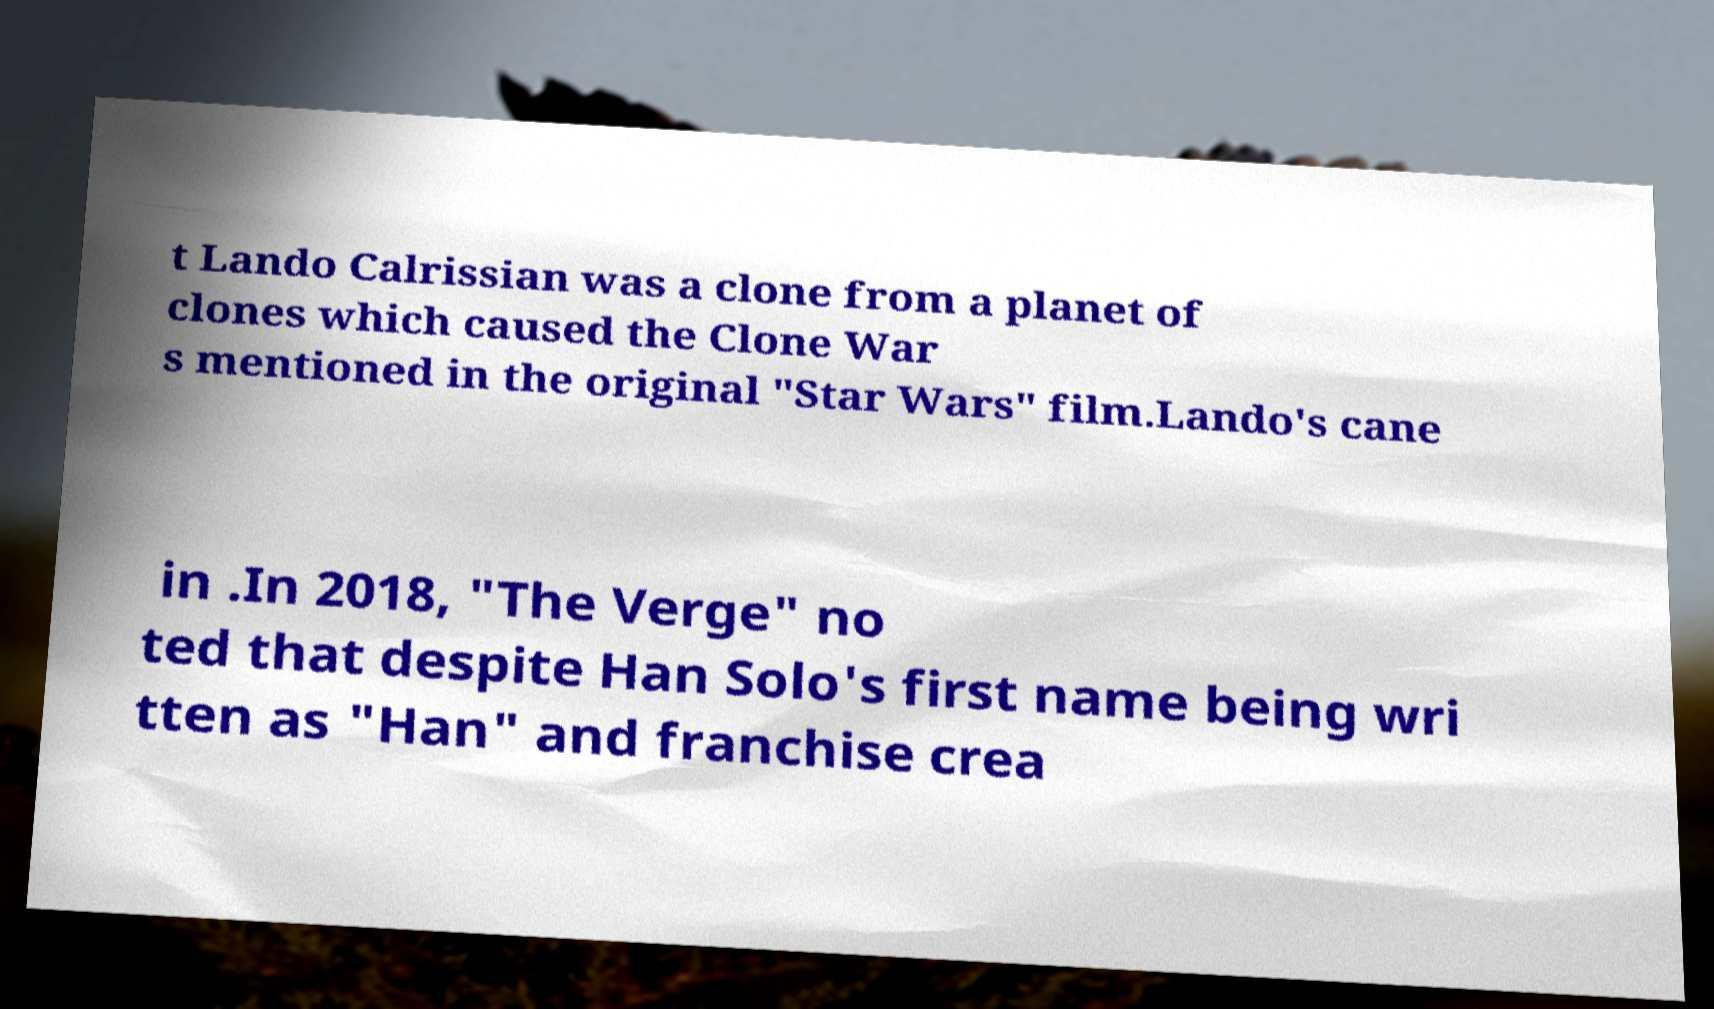Can you read and provide the text displayed in the image?This photo seems to have some interesting text. Can you extract and type it out for me? t Lando Calrissian was a clone from a planet of clones which caused the Clone War s mentioned in the original "Star Wars" film.Lando's cane in .In 2018, "The Verge" no ted that despite Han Solo's first name being wri tten as "Han" and franchise crea 